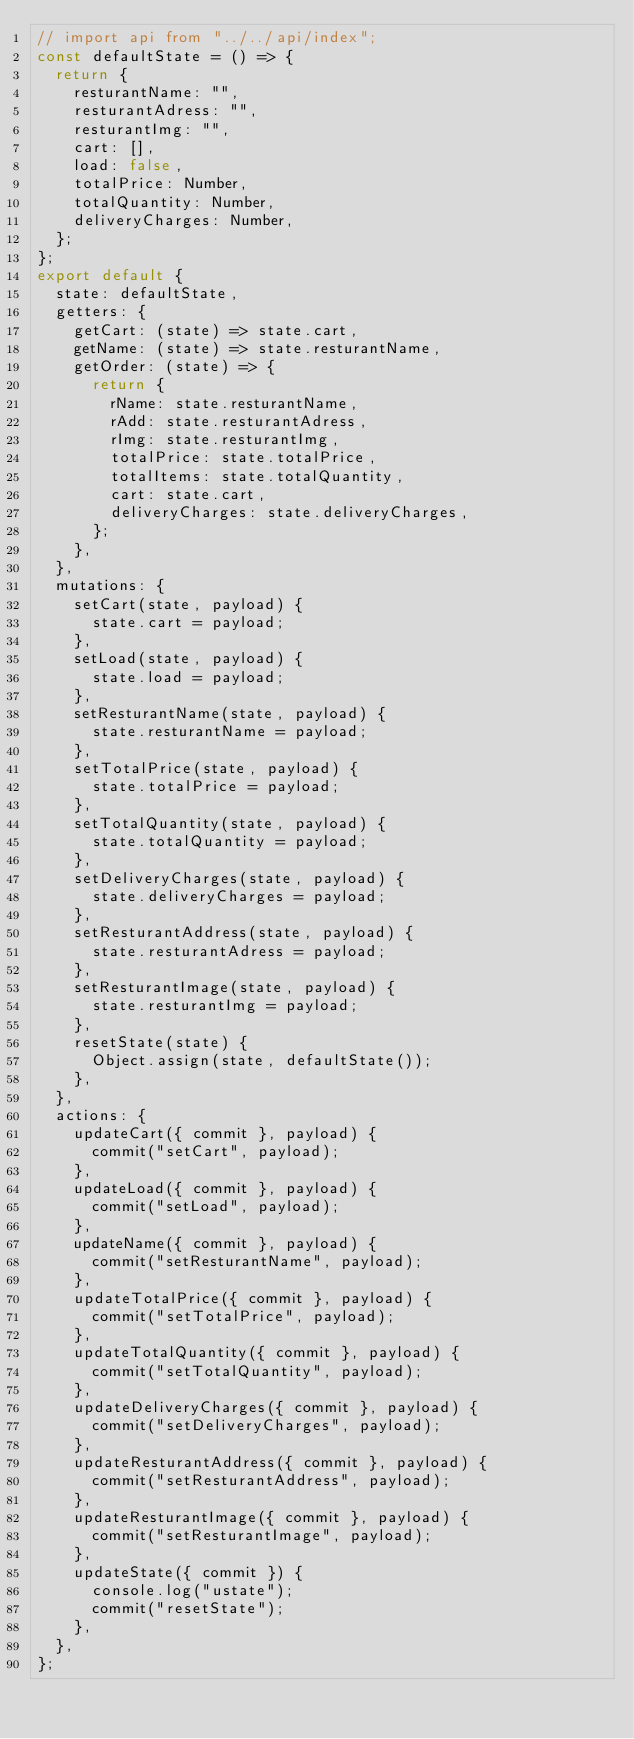<code> <loc_0><loc_0><loc_500><loc_500><_JavaScript_>// import api from "../../api/index";
const defaultState = () => {
	return {
		resturantName: "",
		resturantAdress: "",
		resturantImg: "",
		cart: [],
		load: false,
		totalPrice: Number,
		totalQuantity: Number,
		deliveryCharges: Number,
	};
};
export default {
	state: defaultState,
	getters: {
		getCart: (state) => state.cart,
		getName: (state) => state.resturantName,
		getOrder: (state) => {
			return {
				rName: state.resturantName,
				rAdd: state.resturantAdress,
				rImg: state.resturantImg,
				totalPrice: state.totalPrice,
				totalItems: state.totalQuantity,
				cart: state.cart,
				deliveryCharges: state.deliveryCharges,
			};
		},
	},
	mutations: {
		setCart(state, payload) {
			state.cart = payload;
		},
		setLoad(state, payload) {
			state.load = payload;
		},
		setResturantName(state, payload) {
			state.resturantName = payload;
		},
		setTotalPrice(state, payload) {
			state.totalPrice = payload;
		},
		setTotalQuantity(state, payload) {
			state.totalQuantity = payload;
		},
		setDeliveryCharges(state, payload) {
			state.deliveryCharges = payload;
		},
		setResturantAddress(state, payload) {
			state.resturantAdress = payload;
		},
		setResturantImage(state, payload) {
			state.resturantImg = payload;
		},
		resetState(state) {
			Object.assign(state, defaultState());
		},
	},
	actions: {
		updateCart({ commit }, payload) {
			commit("setCart", payload);
		},
		updateLoad({ commit }, payload) {
			commit("setLoad", payload);
		},
		updateName({ commit }, payload) {
			commit("setResturantName", payload);
		},
		updateTotalPrice({ commit }, payload) {
			commit("setTotalPrice", payload);
		},
		updateTotalQuantity({ commit }, payload) {
			commit("setTotalQuantity", payload);
		},
		updateDeliveryCharges({ commit }, payload) {
			commit("setDeliveryCharges", payload);
		},
		updateResturantAddress({ commit }, payload) {
			commit("setResturantAddress", payload);
		},
		updateResturantImage({ commit }, payload) {
			commit("setResturantImage", payload);
		},
		updateState({ commit }) {
			console.log("ustate");
			commit("resetState");
		},
	},
};
</code> 